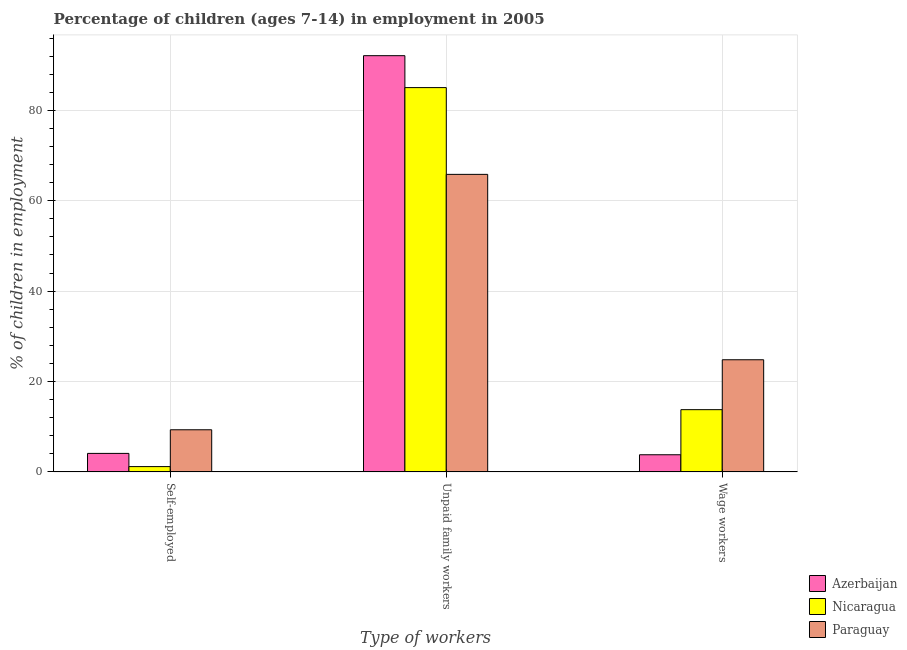How many groups of bars are there?
Provide a succinct answer. 3. How many bars are there on the 2nd tick from the left?
Your answer should be compact. 3. How many bars are there on the 1st tick from the right?
Give a very brief answer. 3. What is the label of the 2nd group of bars from the left?
Give a very brief answer. Unpaid family workers. Across all countries, what is the maximum percentage of children employed as unpaid family workers?
Offer a very short reply. 92.1. In which country was the percentage of children employed as unpaid family workers maximum?
Provide a succinct answer. Azerbaijan. In which country was the percentage of self employed children minimum?
Provide a short and direct response. Nicaragua. What is the total percentage of children employed as unpaid family workers in the graph?
Provide a succinct answer. 242.98. What is the difference between the percentage of children employed as unpaid family workers in Paraguay and that in Nicaragua?
Keep it short and to the point. -19.2. What is the difference between the percentage of children employed as unpaid family workers in Paraguay and the percentage of self employed children in Azerbaijan?
Keep it short and to the point. 61.74. What is the average percentage of children employed as wage workers per country?
Give a very brief answer. 14.13. What is the difference between the percentage of self employed children and percentage of children employed as unpaid family workers in Nicaragua?
Your response must be concise. -83.86. In how many countries, is the percentage of children employed as unpaid family workers greater than 48 %?
Make the answer very short. 3. What is the ratio of the percentage of self employed children in Nicaragua to that in Azerbaijan?
Offer a terse response. 0.29. Is the percentage of children employed as unpaid family workers in Nicaragua less than that in Azerbaijan?
Provide a short and direct response. Yes. Is the difference between the percentage of children employed as wage workers in Paraguay and Nicaragua greater than the difference between the percentage of self employed children in Paraguay and Nicaragua?
Offer a terse response. Yes. What is the difference between the highest and the second highest percentage of children employed as unpaid family workers?
Provide a short and direct response. 7.06. What is the difference between the highest and the lowest percentage of children employed as unpaid family workers?
Give a very brief answer. 26.26. In how many countries, is the percentage of self employed children greater than the average percentage of self employed children taken over all countries?
Provide a succinct answer. 1. Is the sum of the percentage of children employed as wage workers in Nicaragua and Azerbaijan greater than the maximum percentage of self employed children across all countries?
Make the answer very short. Yes. What does the 2nd bar from the left in Unpaid family workers represents?
Offer a terse response. Nicaragua. What does the 3rd bar from the right in Wage workers represents?
Give a very brief answer. Azerbaijan. How many bars are there?
Give a very brief answer. 9. What is the difference between two consecutive major ticks on the Y-axis?
Keep it short and to the point. 20. Are the values on the major ticks of Y-axis written in scientific E-notation?
Keep it short and to the point. No. Does the graph contain any zero values?
Provide a succinct answer. No. Does the graph contain grids?
Offer a terse response. Yes. What is the title of the graph?
Keep it short and to the point. Percentage of children (ages 7-14) in employment in 2005. Does "Seychelles" appear as one of the legend labels in the graph?
Your answer should be very brief. No. What is the label or title of the X-axis?
Your answer should be compact. Type of workers. What is the label or title of the Y-axis?
Offer a terse response. % of children in employment. What is the % of children in employment in Azerbaijan in Self-employed?
Your answer should be compact. 4.1. What is the % of children in employment of Nicaragua in Self-employed?
Provide a short and direct response. 1.18. What is the % of children in employment in Paraguay in Self-employed?
Keep it short and to the point. 9.33. What is the % of children in employment in Azerbaijan in Unpaid family workers?
Keep it short and to the point. 92.1. What is the % of children in employment of Nicaragua in Unpaid family workers?
Ensure brevity in your answer.  85.04. What is the % of children in employment of Paraguay in Unpaid family workers?
Make the answer very short. 65.84. What is the % of children in employment in Nicaragua in Wage workers?
Your answer should be compact. 13.78. What is the % of children in employment in Paraguay in Wage workers?
Your answer should be very brief. 24.82. Across all Type of workers, what is the maximum % of children in employment of Azerbaijan?
Offer a terse response. 92.1. Across all Type of workers, what is the maximum % of children in employment of Nicaragua?
Provide a short and direct response. 85.04. Across all Type of workers, what is the maximum % of children in employment of Paraguay?
Offer a very short reply. 65.84. Across all Type of workers, what is the minimum % of children in employment of Azerbaijan?
Give a very brief answer. 3.8. Across all Type of workers, what is the minimum % of children in employment in Nicaragua?
Your answer should be very brief. 1.18. Across all Type of workers, what is the minimum % of children in employment of Paraguay?
Your answer should be very brief. 9.33. What is the total % of children in employment of Paraguay in the graph?
Keep it short and to the point. 99.99. What is the difference between the % of children in employment of Azerbaijan in Self-employed and that in Unpaid family workers?
Ensure brevity in your answer.  -88. What is the difference between the % of children in employment of Nicaragua in Self-employed and that in Unpaid family workers?
Offer a very short reply. -83.86. What is the difference between the % of children in employment in Paraguay in Self-employed and that in Unpaid family workers?
Offer a very short reply. -56.51. What is the difference between the % of children in employment of Paraguay in Self-employed and that in Wage workers?
Offer a very short reply. -15.49. What is the difference between the % of children in employment of Azerbaijan in Unpaid family workers and that in Wage workers?
Provide a succinct answer. 88.3. What is the difference between the % of children in employment in Nicaragua in Unpaid family workers and that in Wage workers?
Your answer should be compact. 71.26. What is the difference between the % of children in employment in Paraguay in Unpaid family workers and that in Wage workers?
Your answer should be very brief. 41.02. What is the difference between the % of children in employment in Azerbaijan in Self-employed and the % of children in employment in Nicaragua in Unpaid family workers?
Make the answer very short. -80.94. What is the difference between the % of children in employment of Azerbaijan in Self-employed and the % of children in employment of Paraguay in Unpaid family workers?
Give a very brief answer. -61.74. What is the difference between the % of children in employment of Nicaragua in Self-employed and the % of children in employment of Paraguay in Unpaid family workers?
Provide a succinct answer. -64.66. What is the difference between the % of children in employment of Azerbaijan in Self-employed and the % of children in employment of Nicaragua in Wage workers?
Ensure brevity in your answer.  -9.68. What is the difference between the % of children in employment in Azerbaijan in Self-employed and the % of children in employment in Paraguay in Wage workers?
Ensure brevity in your answer.  -20.72. What is the difference between the % of children in employment of Nicaragua in Self-employed and the % of children in employment of Paraguay in Wage workers?
Provide a succinct answer. -23.64. What is the difference between the % of children in employment of Azerbaijan in Unpaid family workers and the % of children in employment of Nicaragua in Wage workers?
Make the answer very short. 78.32. What is the difference between the % of children in employment of Azerbaijan in Unpaid family workers and the % of children in employment of Paraguay in Wage workers?
Ensure brevity in your answer.  67.28. What is the difference between the % of children in employment in Nicaragua in Unpaid family workers and the % of children in employment in Paraguay in Wage workers?
Your answer should be compact. 60.22. What is the average % of children in employment of Azerbaijan per Type of workers?
Provide a succinct answer. 33.33. What is the average % of children in employment in Nicaragua per Type of workers?
Make the answer very short. 33.33. What is the average % of children in employment of Paraguay per Type of workers?
Make the answer very short. 33.33. What is the difference between the % of children in employment in Azerbaijan and % of children in employment in Nicaragua in Self-employed?
Your answer should be very brief. 2.92. What is the difference between the % of children in employment of Azerbaijan and % of children in employment of Paraguay in Self-employed?
Offer a very short reply. -5.23. What is the difference between the % of children in employment of Nicaragua and % of children in employment of Paraguay in Self-employed?
Your response must be concise. -8.15. What is the difference between the % of children in employment in Azerbaijan and % of children in employment in Nicaragua in Unpaid family workers?
Provide a short and direct response. 7.06. What is the difference between the % of children in employment in Azerbaijan and % of children in employment in Paraguay in Unpaid family workers?
Your answer should be compact. 26.26. What is the difference between the % of children in employment in Nicaragua and % of children in employment in Paraguay in Unpaid family workers?
Keep it short and to the point. 19.2. What is the difference between the % of children in employment in Azerbaijan and % of children in employment in Nicaragua in Wage workers?
Your answer should be very brief. -9.98. What is the difference between the % of children in employment of Azerbaijan and % of children in employment of Paraguay in Wage workers?
Offer a very short reply. -21.02. What is the difference between the % of children in employment in Nicaragua and % of children in employment in Paraguay in Wage workers?
Offer a terse response. -11.04. What is the ratio of the % of children in employment of Azerbaijan in Self-employed to that in Unpaid family workers?
Give a very brief answer. 0.04. What is the ratio of the % of children in employment in Nicaragua in Self-employed to that in Unpaid family workers?
Provide a short and direct response. 0.01. What is the ratio of the % of children in employment of Paraguay in Self-employed to that in Unpaid family workers?
Ensure brevity in your answer.  0.14. What is the ratio of the % of children in employment in Azerbaijan in Self-employed to that in Wage workers?
Your answer should be very brief. 1.08. What is the ratio of the % of children in employment in Nicaragua in Self-employed to that in Wage workers?
Provide a short and direct response. 0.09. What is the ratio of the % of children in employment of Paraguay in Self-employed to that in Wage workers?
Your response must be concise. 0.38. What is the ratio of the % of children in employment of Azerbaijan in Unpaid family workers to that in Wage workers?
Offer a very short reply. 24.24. What is the ratio of the % of children in employment in Nicaragua in Unpaid family workers to that in Wage workers?
Provide a succinct answer. 6.17. What is the ratio of the % of children in employment of Paraguay in Unpaid family workers to that in Wage workers?
Your answer should be very brief. 2.65. What is the difference between the highest and the second highest % of children in employment of Azerbaijan?
Your answer should be very brief. 88. What is the difference between the highest and the second highest % of children in employment in Nicaragua?
Provide a succinct answer. 71.26. What is the difference between the highest and the second highest % of children in employment in Paraguay?
Provide a succinct answer. 41.02. What is the difference between the highest and the lowest % of children in employment of Azerbaijan?
Your answer should be very brief. 88.3. What is the difference between the highest and the lowest % of children in employment in Nicaragua?
Your answer should be compact. 83.86. What is the difference between the highest and the lowest % of children in employment in Paraguay?
Provide a short and direct response. 56.51. 